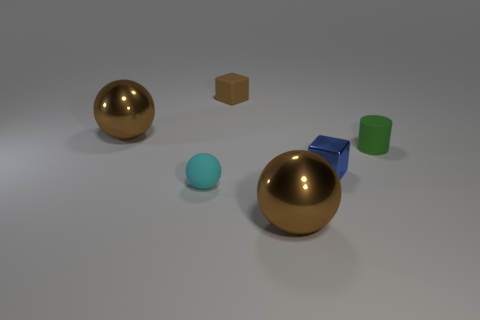Add 1 yellow spheres. How many objects exist? 7 Subtract all cylinders. How many objects are left? 5 Add 3 small yellow metal balls. How many small yellow metal balls exist? 3 Subtract 0 gray cylinders. How many objects are left? 6 Subtract all green cylinders. Subtract all large brown metal objects. How many objects are left? 3 Add 6 large objects. How many large objects are left? 8 